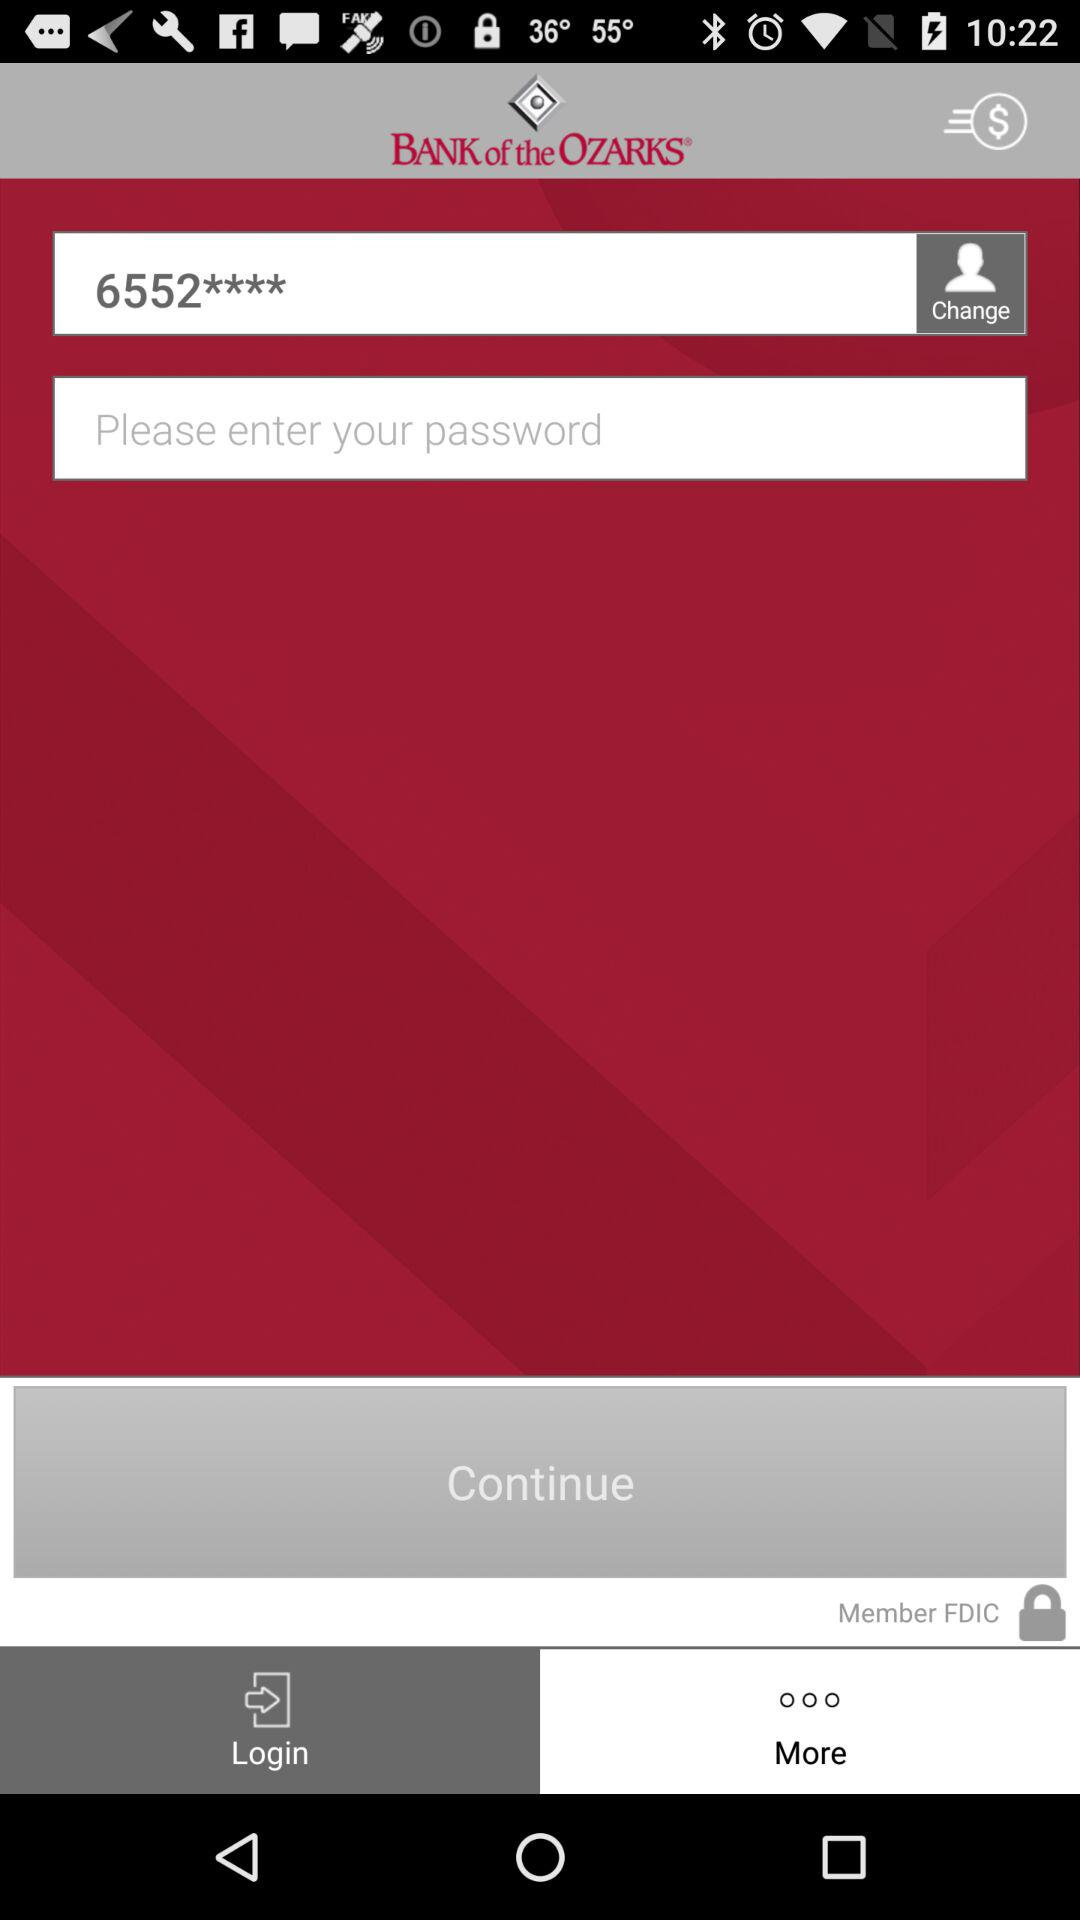How many text inputs are in the login screen?
Answer the question using a single word or phrase. 2 